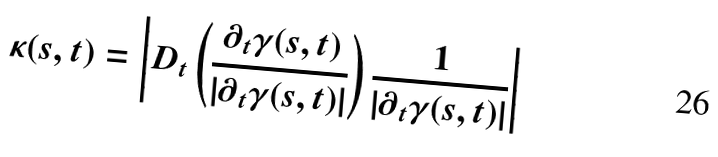Convert formula to latex. <formula><loc_0><loc_0><loc_500><loc_500>\kappa ( s , t ) = \left | D _ { t } \left ( \frac { \partial _ { t } \gamma ( s , t ) } { | \partial _ { t } \gamma ( s , t ) | } \right ) \frac { 1 } { | \partial _ { t } \gamma ( s , t ) | } \right |</formula> 